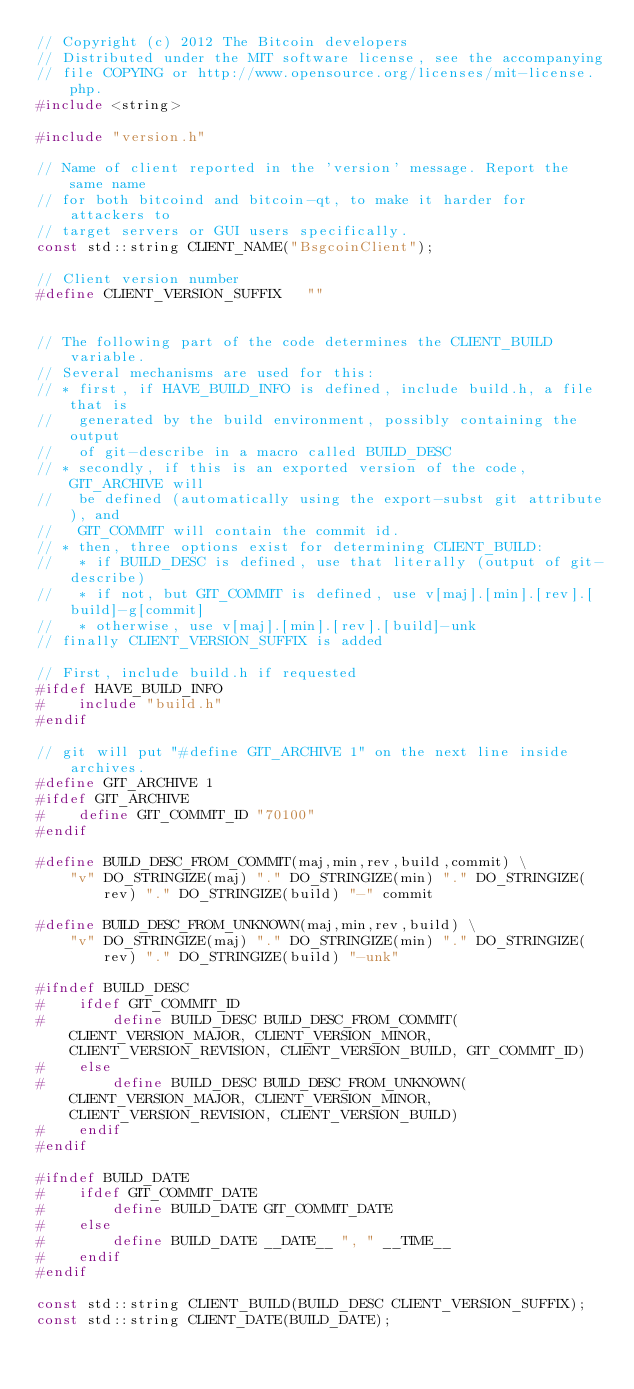<code> <loc_0><loc_0><loc_500><loc_500><_C++_>// Copyright (c) 2012 The Bitcoin developers
// Distributed under the MIT software license, see the accompanying
// file COPYING or http://www.opensource.org/licenses/mit-license.php.
#include <string>

#include "version.h"

// Name of client reported in the 'version' message. Report the same name
// for both bitcoind and bitcoin-qt, to make it harder for attackers to
// target servers or GUI users specifically.
const std::string CLIENT_NAME("BsgcoinClient");

// Client version number
#define CLIENT_VERSION_SUFFIX   ""


// The following part of the code determines the CLIENT_BUILD variable.
// Several mechanisms are used for this:
// * first, if HAVE_BUILD_INFO is defined, include build.h, a file that is
//   generated by the build environment, possibly containing the output
//   of git-describe in a macro called BUILD_DESC
// * secondly, if this is an exported version of the code, GIT_ARCHIVE will
//   be defined (automatically using the export-subst git attribute), and
//   GIT_COMMIT will contain the commit id.
// * then, three options exist for determining CLIENT_BUILD:
//   * if BUILD_DESC is defined, use that literally (output of git-describe)
//   * if not, but GIT_COMMIT is defined, use v[maj].[min].[rev].[build]-g[commit]
//   * otherwise, use v[maj].[min].[rev].[build]-unk
// finally CLIENT_VERSION_SUFFIX is added

// First, include build.h if requested
#ifdef HAVE_BUILD_INFO
#    include "build.h"
#endif

// git will put "#define GIT_ARCHIVE 1" on the next line inside archives. 
#define GIT_ARCHIVE 1
#ifdef GIT_ARCHIVE
#    define GIT_COMMIT_ID "70100"
#endif

#define BUILD_DESC_FROM_COMMIT(maj,min,rev,build,commit) \
    "v" DO_STRINGIZE(maj) "." DO_STRINGIZE(min) "." DO_STRINGIZE(rev) "." DO_STRINGIZE(build) "-" commit

#define BUILD_DESC_FROM_UNKNOWN(maj,min,rev,build) \
    "v" DO_STRINGIZE(maj) "." DO_STRINGIZE(min) "." DO_STRINGIZE(rev) "." DO_STRINGIZE(build) "-unk"

#ifndef BUILD_DESC
#    ifdef GIT_COMMIT_ID
#        define BUILD_DESC BUILD_DESC_FROM_COMMIT(CLIENT_VERSION_MAJOR, CLIENT_VERSION_MINOR, CLIENT_VERSION_REVISION, CLIENT_VERSION_BUILD, GIT_COMMIT_ID)
#    else
#        define BUILD_DESC BUILD_DESC_FROM_UNKNOWN(CLIENT_VERSION_MAJOR, CLIENT_VERSION_MINOR, CLIENT_VERSION_REVISION, CLIENT_VERSION_BUILD)
#    endif
#endif

#ifndef BUILD_DATE
#    ifdef GIT_COMMIT_DATE
#        define BUILD_DATE GIT_COMMIT_DATE
#    else
#        define BUILD_DATE __DATE__ ", " __TIME__
#    endif
#endif

const std::string CLIENT_BUILD(BUILD_DESC CLIENT_VERSION_SUFFIX);
const std::string CLIENT_DATE(BUILD_DATE);
</code> 